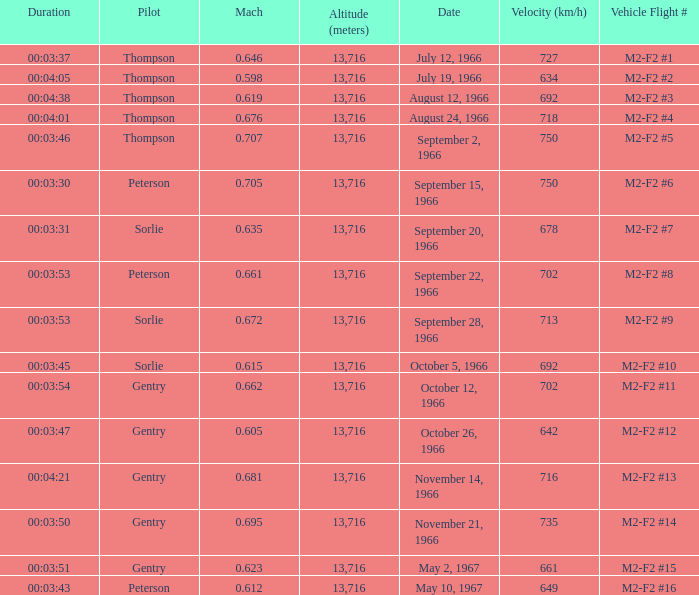What is the Mach with Vehicle Flight # m2-f2 #8 and an Altitude (meters) greater than 13,716? None. 